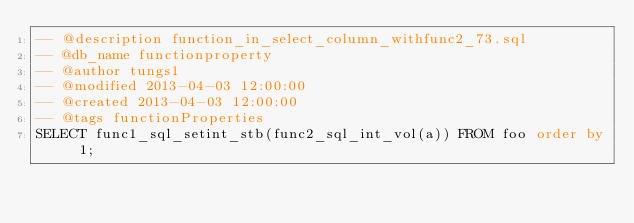<code> <loc_0><loc_0><loc_500><loc_500><_SQL_>-- @description function_in_select_column_withfunc2_73.sql
-- @db_name functionproperty
-- @author tungs1
-- @modified 2013-04-03 12:00:00
-- @created 2013-04-03 12:00:00
-- @tags functionProperties 
SELECT func1_sql_setint_stb(func2_sql_int_vol(a)) FROM foo order by 1; 
</code> 